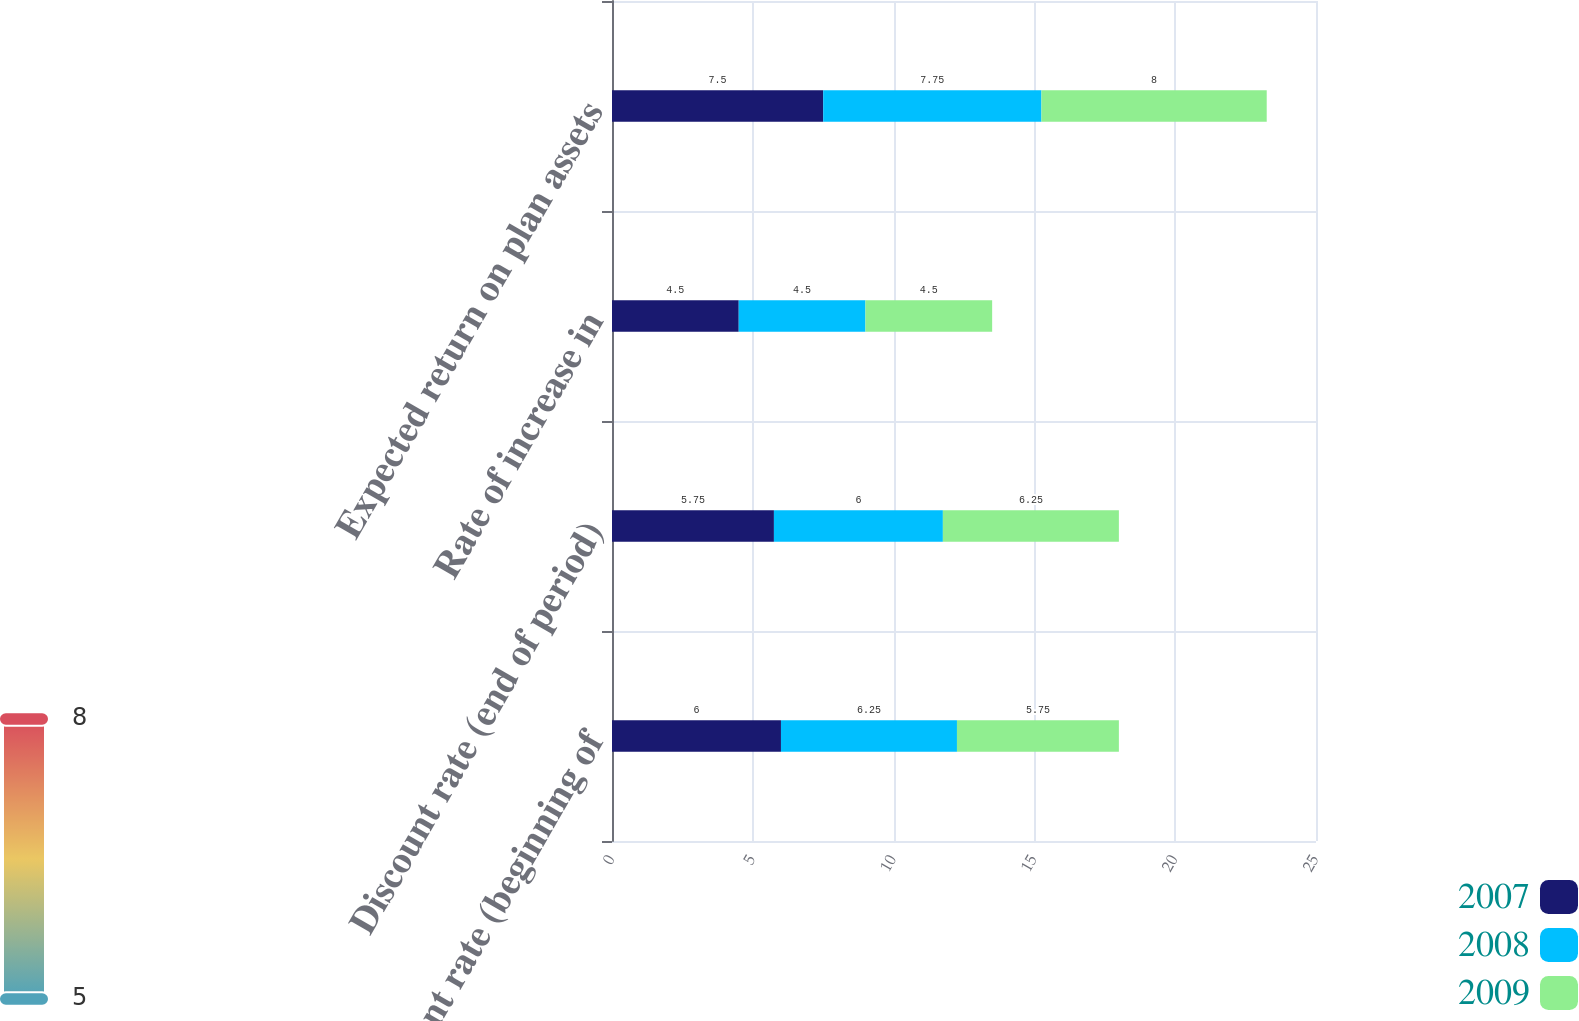Convert chart. <chart><loc_0><loc_0><loc_500><loc_500><stacked_bar_chart><ecel><fcel>Discount rate (beginning of<fcel>Discount rate (end of period)<fcel>Rate of increase in<fcel>Expected return on plan assets<nl><fcel>2007<fcel>6<fcel>5.75<fcel>4.5<fcel>7.5<nl><fcel>2008<fcel>6.25<fcel>6<fcel>4.5<fcel>7.75<nl><fcel>2009<fcel>5.75<fcel>6.25<fcel>4.5<fcel>8<nl></chart> 